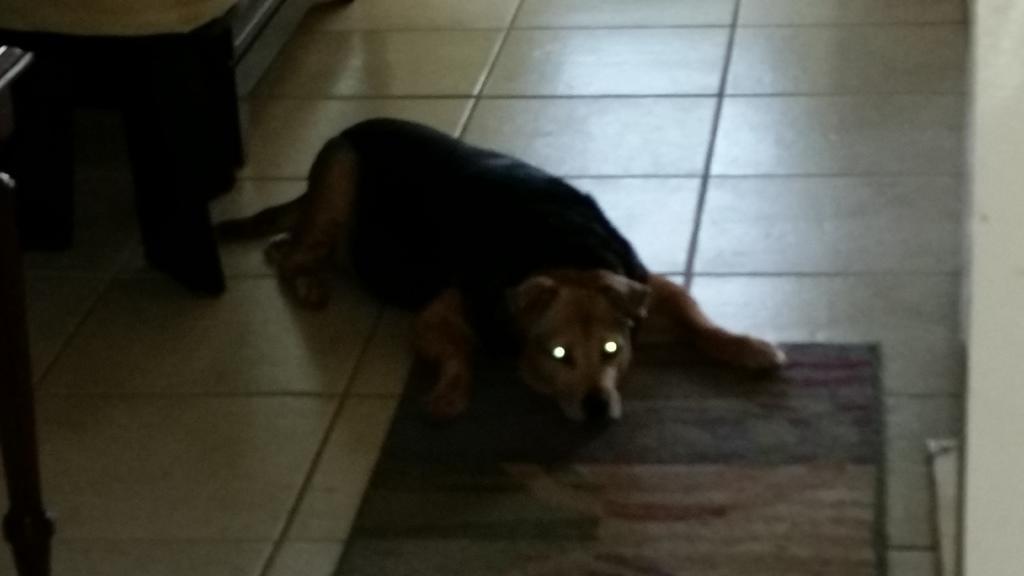In one or two sentences, can you explain what this image depicts? In the foreground of this image, there is a dog lying down on the floor and there is also a carpet on the floor. There is a table like an object on the top left corner. 